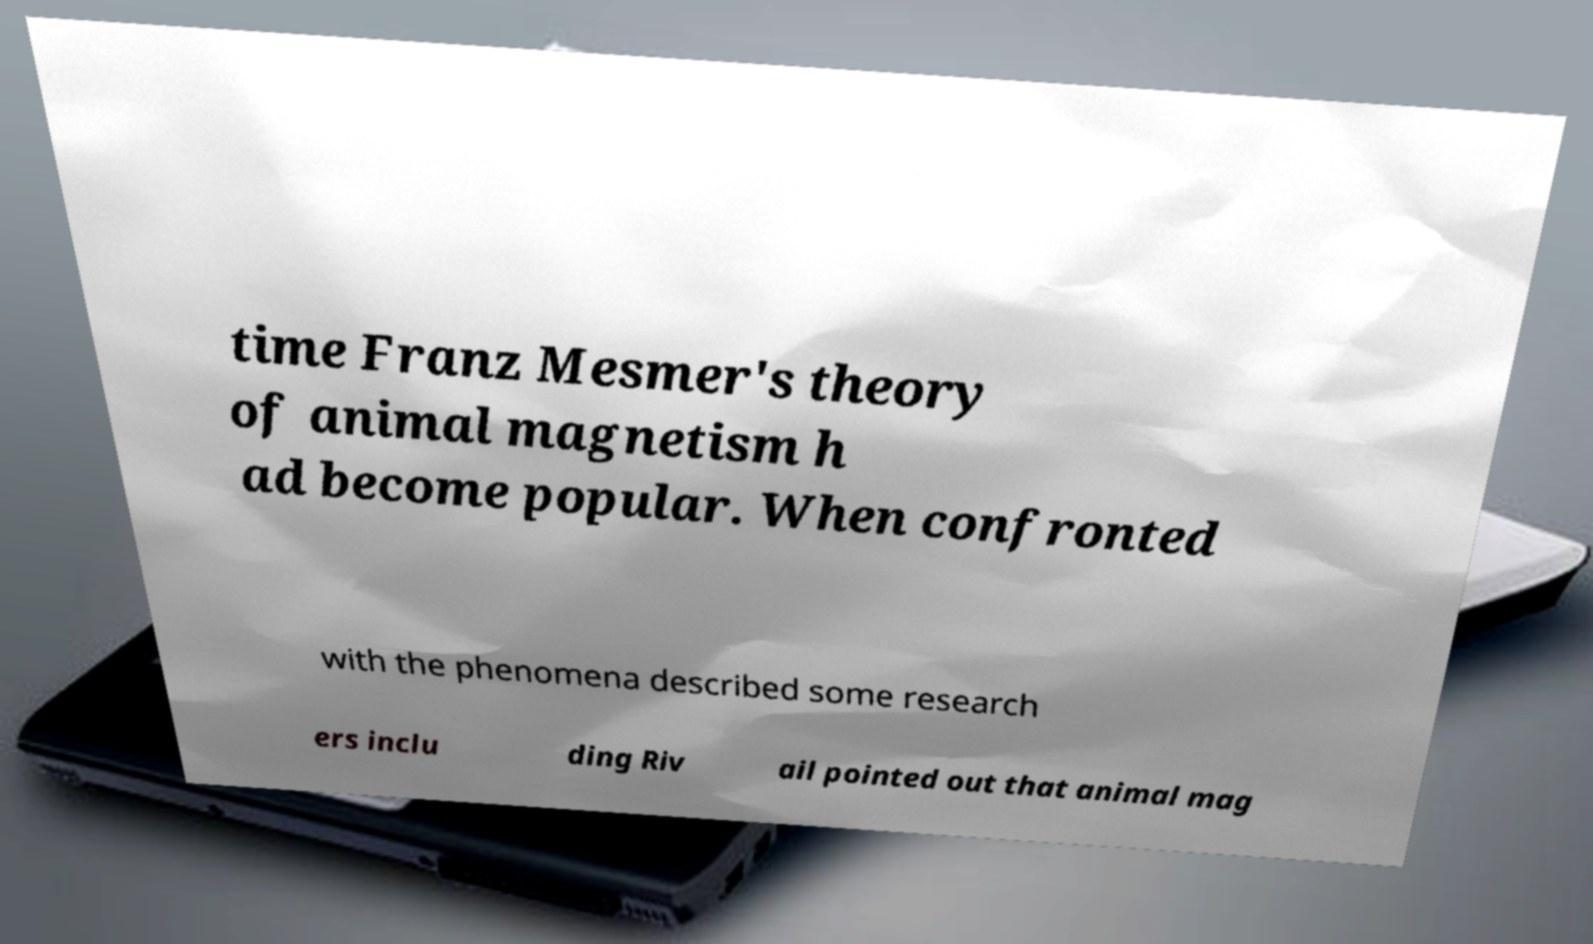Can you accurately transcribe the text from the provided image for me? time Franz Mesmer's theory of animal magnetism h ad become popular. When confronted with the phenomena described some research ers inclu ding Riv ail pointed out that animal mag 